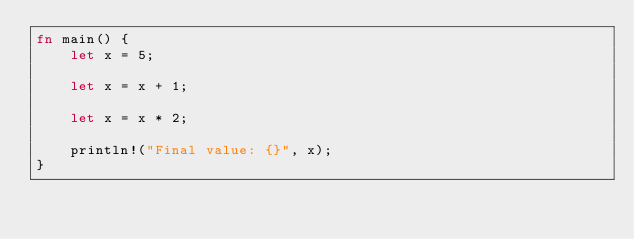Convert code to text. <code><loc_0><loc_0><loc_500><loc_500><_Rust_>fn main() {
    let x = 5;

    let x = x + 1;

    let x = x * 2;

    println!("Final value: {}", x);
}
</code> 